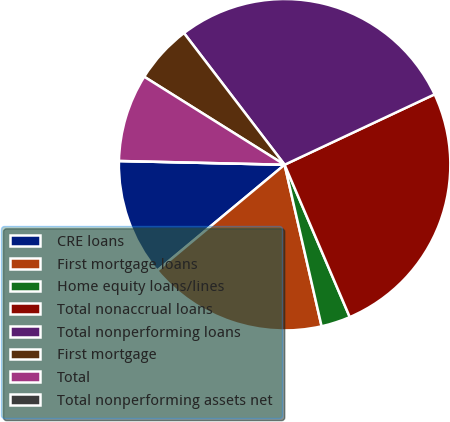<chart> <loc_0><loc_0><loc_500><loc_500><pie_chart><fcel>CRE loans<fcel>First mortgage loans<fcel>Home equity loans/lines<fcel>Total nonaccrual loans<fcel>Total nonperforming loans<fcel>First mortgage<fcel>Total<fcel>Total nonperforming assets net<nl><fcel>11.4%<fcel>17.54%<fcel>2.85%<fcel>25.55%<fcel>28.4%<fcel>5.7%<fcel>8.55%<fcel>0.0%<nl></chart> 